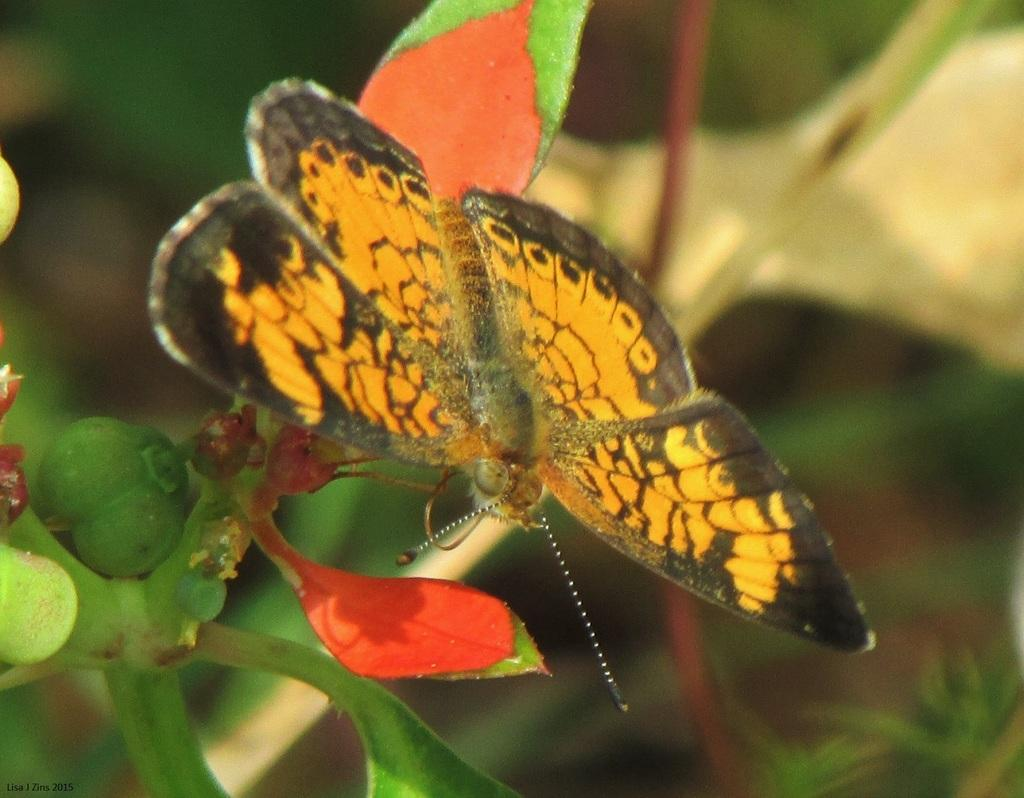What is the main subject of the image? The main subject of the image is a butterfly. Where is the butterfly located in the image? The butterfly is on a plant. Can you describe the background of the image? The background of the image is blurred. What type of structure can be seen in the background of the image? There is no structure visible in the background of the image; it is blurred. What place is the butterfly visiting in the image? The image does not provide information about the butterfly visiting a specific place. 